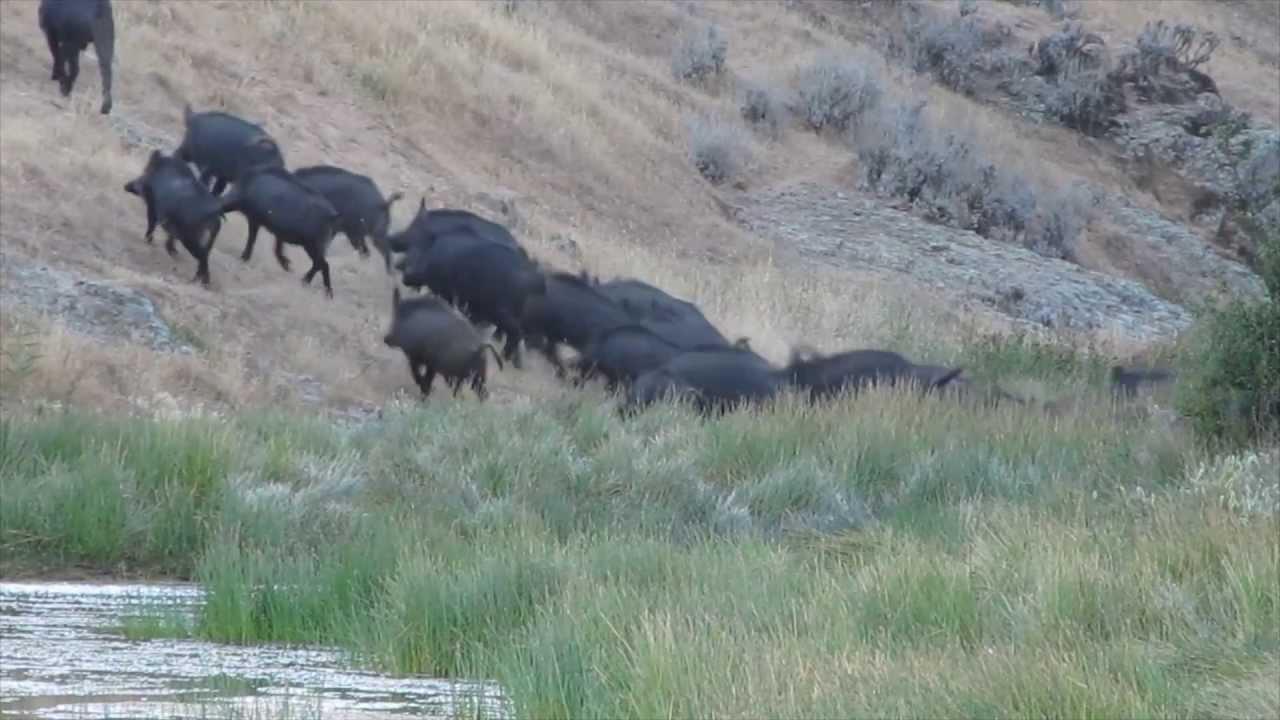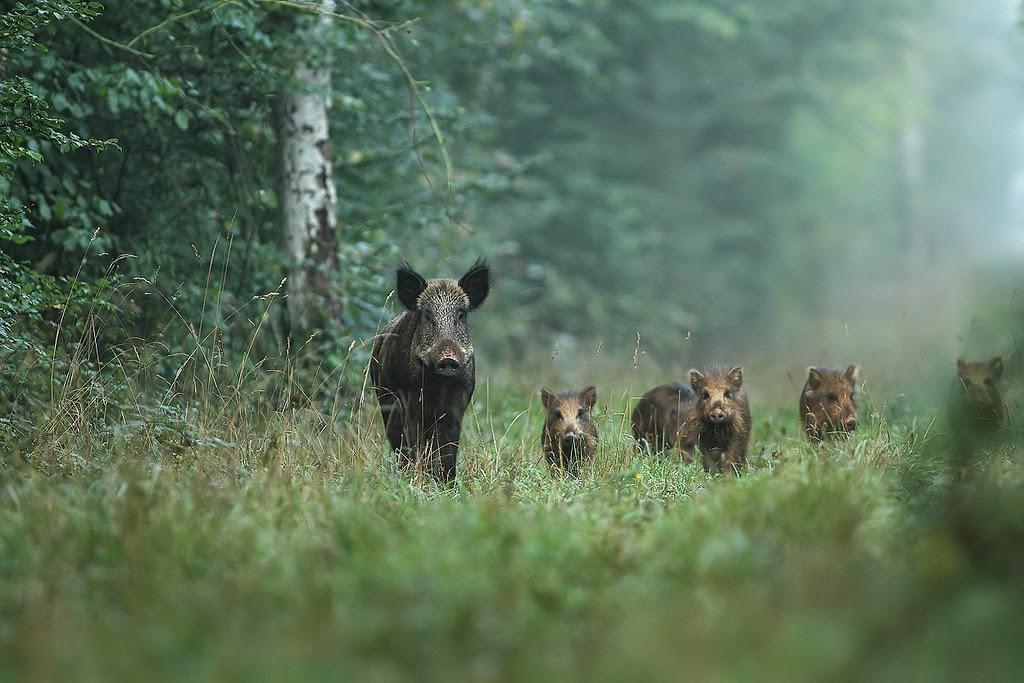The first image is the image on the left, the second image is the image on the right. Analyze the images presented: Is the assertion "At least one wild animal is wallowing in the mud." valid? Answer yes or no. No. The first image is the image on the left, the second image is the image on the right. Assess this claim about the two images: "An image shows at least one wild pig in the mud.". Correct or not? Answer yes or no. No. 